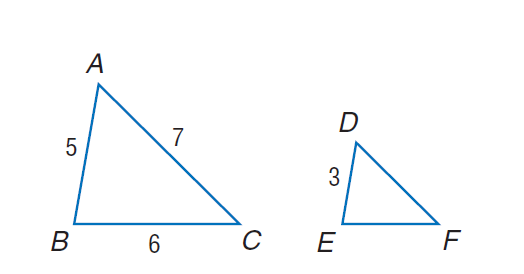Answer the mathemtical geometry problem and directly provide the correct option letter.
Question: Find the perimeter of the given triangle \triangle D E F, if \triangle A B C \sim \triangle D E F, A B = 5, B C = 6, A C = 7, and D E = 3.
Choices: A: 9.2 B: 10.8 C: 18 D: 31.7 B 